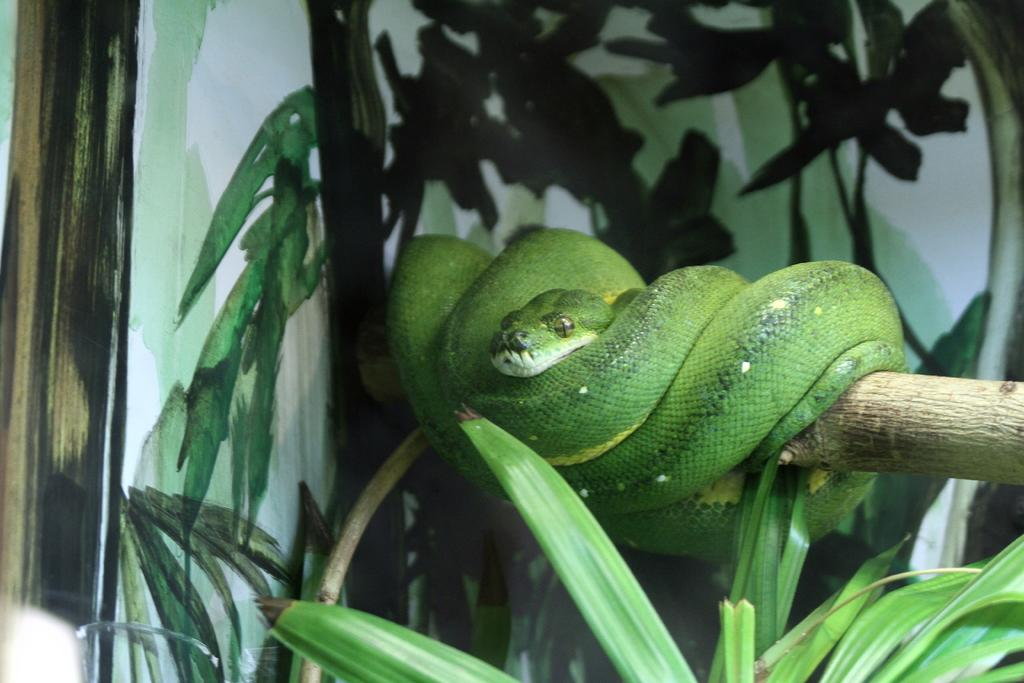What type of animal is in the image? There is a green color snake in the image. Where is the snake located? The snake is on a log. What can be seen at the bottom of the image? There are plants at the bottom of the image. What type of apparel is the fowl wearing in the image? There is no fowl or apparel present in the image; it features a green color snake on a log. 